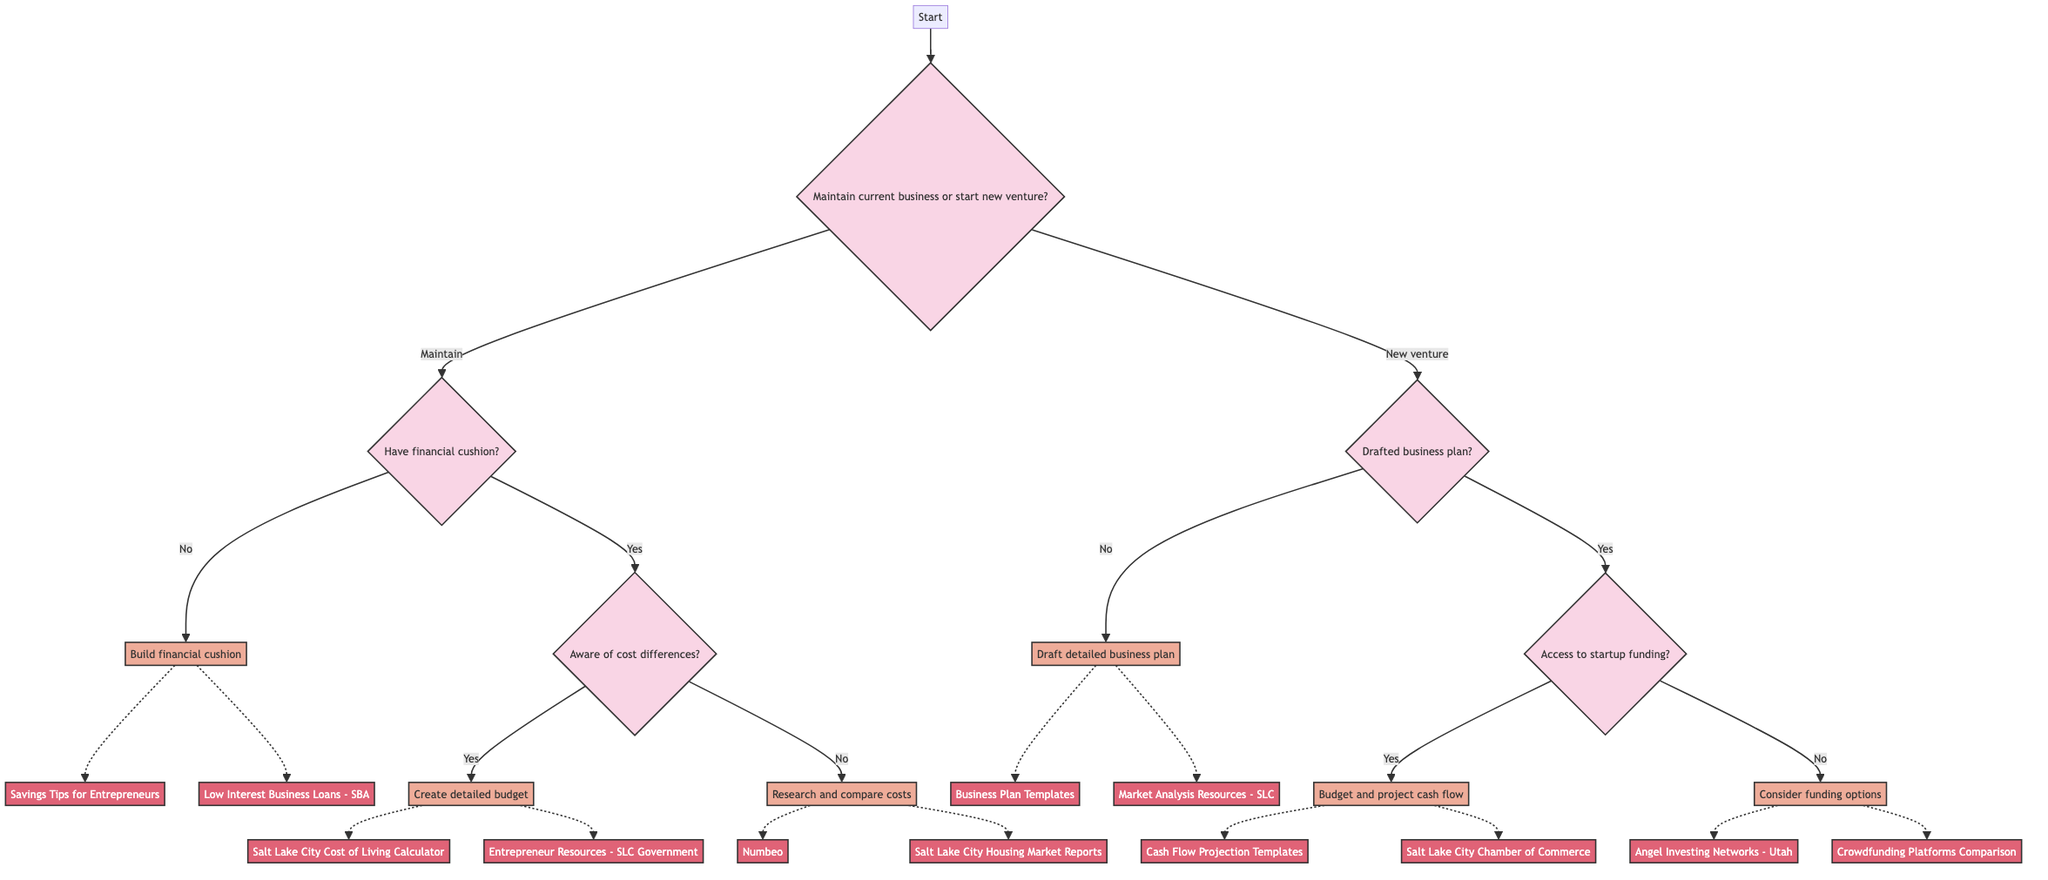What are the two main options presented at the start of the diagram? The start node presents two main options: "Maintain current business" or "Start new venture". These are the two paths the decision tree offers for the user's consideration.
Answer: Maintain current business, Start new venture What happens if you have a financial cushion but are not aware of cost differences? If you have a financial cushion, you move to the question regarding awareness of cost differences. If the answer is "no", the action would be to "Research and compare specific costs" to understand the expenses involved in relocating.
Answer: Research and compare specific costs How many options are available after deciding to maintain your current business? After deciding to maintain the current business, there are three options: "Have financial cushion?", "Aware of cost differences?", and the respective actions based on their answers. Therefore, there are 3 paths leading to different actions.
Answer: Three If someone has not drafted a business plan and wants to start a new venture, what should they do? If a business plan has not been drafted, the action is to "Draft a detailed business plan" which must include market analysis, product/service strategy, and financial projections. This is essential for starting a new venture.
Answer: Draft a detailed business plan What is the follow-up action if there is access to startup funding? If there is access to startup funding after drafting a business plan, the follow-up action is to "Budget and project cash flow" based on expected revenues and costs. This ensures proper financial planning before launching the new venture.
Answer: Budget and project cash flow Which resources are suggested for creating a detailed budget when aware of cost differences? When aware of cost differences, the suggested resources for creating a detailed budget include the "Salt Lake City Cost of Living Calculator" and "Entrepreneur Resources - Salt Lake City Government". These tools help in compiling an accurate financial overview.
Answer: Salt Lake City Cost of Living Calculator, Entrepreneur Resources - Salt Lake City Government What funding options are recommended if there is no access to startup funding? If there is no access to startup funding, the recommended options include considering "grants, angel investors, and crowdfunding platforms" as alternative funding sources to support the new venture. These provide viable financial assistance opportunities for entrepreneurs.
Answer: Grants, angel investors, crowdfunding platforms How does the decision tree guide someone with no financial cushion? The decision tree guides someone with no financial cushion to take the action of "Building a financial cushion by setting aside savings each month" or seeking low-interest loans, ensuring they prepare adequately before relocation or starting a business.
Answer: Build financial cushion What are the resources provided for researching and comparing costs in Salt Lake County? The resources provided for researching and comparing costs are "Numbeo" and "Salt Lake City Housing Market Reports". These are valuable tools that offer data and insights on various living costs.
Answer: Numbeo, Salt Lake City Housing Market Reports 